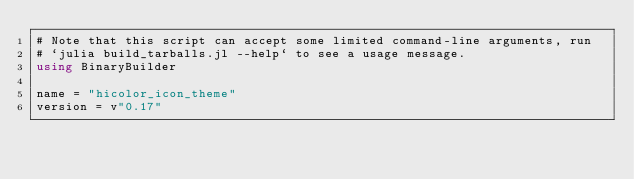<code> <loc_0><loc_0><loc_500><loc_500><_Julia_># Note that this script can accept some limited command-line arguments, run
# `julia build_tarballs.jl --help` to see a usage message.
using BinaryBuilder

name = "hicolor_icon_theme"
version = v"0.17"
</code> 